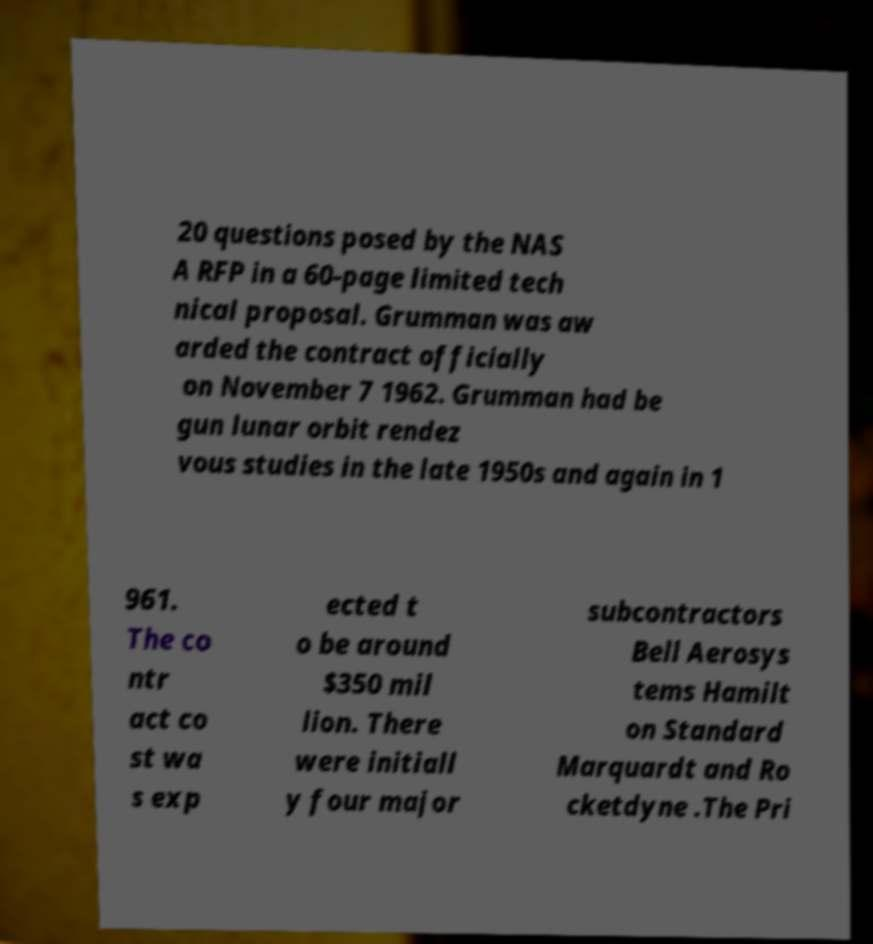For documentation purposes, I need the text within this image transcribed. Could you provide that? 20 questions posed by the NAS A RFP in a 60-page limited tech nical proposal. Grumman was aw arded the contract officially on November 7 1962. Grumman had be gun lunar orbit rendez vous studies in the late 1950s and again in 1 961. The co ntr act co st wa s exp ected t o be around $350 mil lion. There were initiall y four major subcontractors Bell Aerosys tems Hamilt on Standard Marquardt and Ro cketdyne .The Pri 